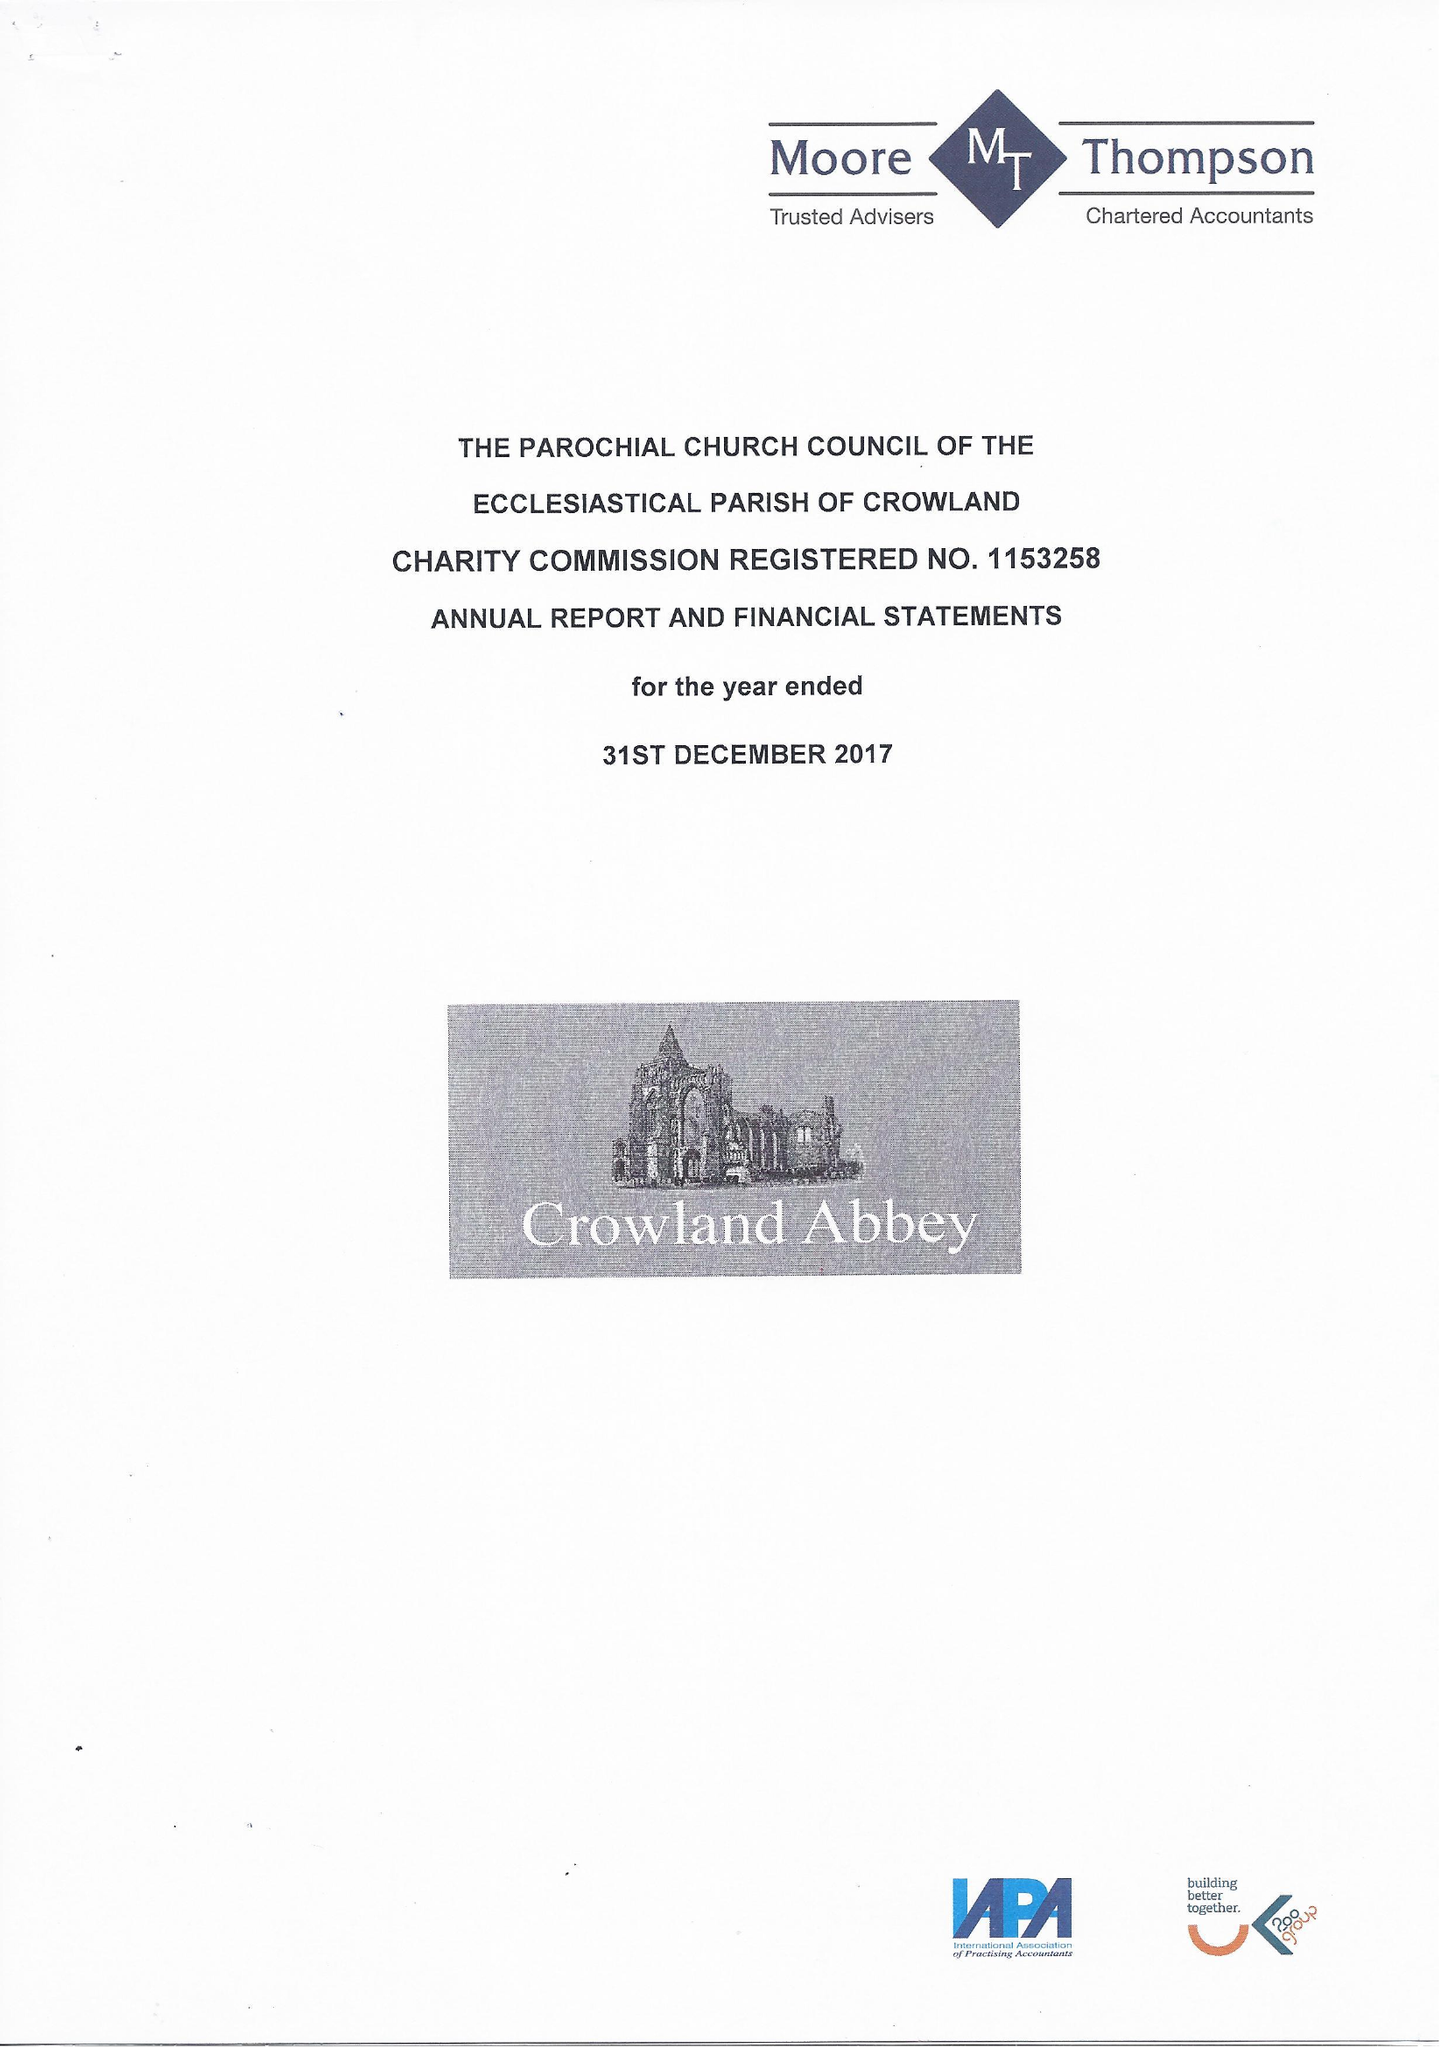What is the value for the report_date?
Answer the question using a single word or phrase. 2017-12-31 